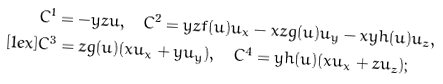Convert formula to latex. <formula><loc_0><loc_0><loc_500><loc_500>& C ^ { 1 } = - y z u , \quad C ^ { 2 } = y z f ( u ) u _ { x } - x z g ( u ) u _ { y } - x y h ( u ) u _ { z } , \\ [ 1 e x ] & C ^ { 3 } = z g ( u ) ( x u _ { x } + y u _ { y } ) , \quad C ^ { 4 } = y h ( u ) ( x u _ { x } + z u _ { z } ) ;</formula> 